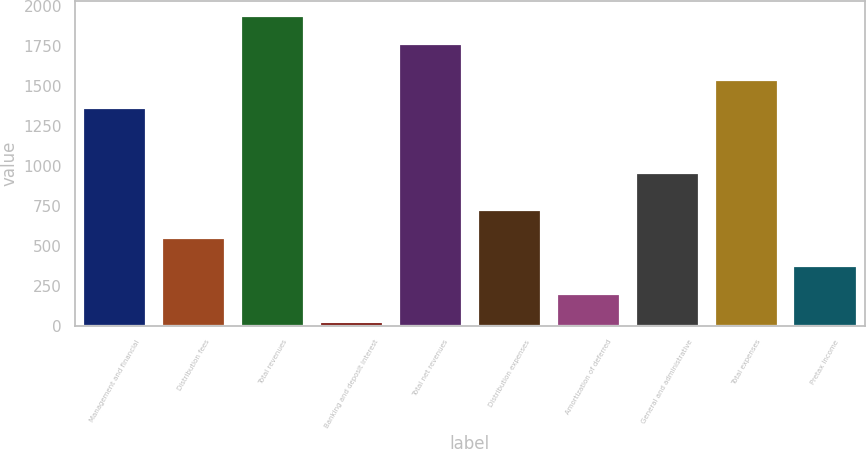Convert chart. <chart><loc_0><loc_0><loc_500><loc_500><bar_chart><fcel>Management and financial<fcel>Distribution fees<fcel>Total revenues<fcel>Banking and deposit interest<fcel>Total net revenues<fcel>Distribution expenses<fcel>Amortization of deferred<fcel>General and administrative<fcel>Total expenses<fcel>Pretax income<nl><fcel>1362<fcel>548.6<fcel>1938.2<fcel>20<fcel>1762<fcel>724.8<fcel>196.2<fcel>958<fcel>1538.2<fcel>372.4<nl></chart> 